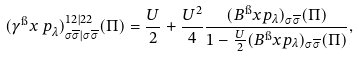<formula> <loc_0><loc_0><loc_500><loc_500>( \gamma ^ { \i } x { \, p } _ { \lambda } ) ^ { 1 2 | 2 2 } _ { \sigma \overline { \sigma } | \sigma \overline { \sigma } } ( \Pi ) = \frac { U } { 2 } + \frac { U ^ { 2 } } { 4 } \frac { ( B ^ { \i } x { p } _ { \lambda } ) _ { \sigma \overline { \sigma } } ( \Pi ) } { 1 - \frac { U } { 2 } ( B ^ { \i } x { p } _ { \lambda } ) _ { \sigma \overline { \sigma } } ( \Pi ) } ,</formula> 